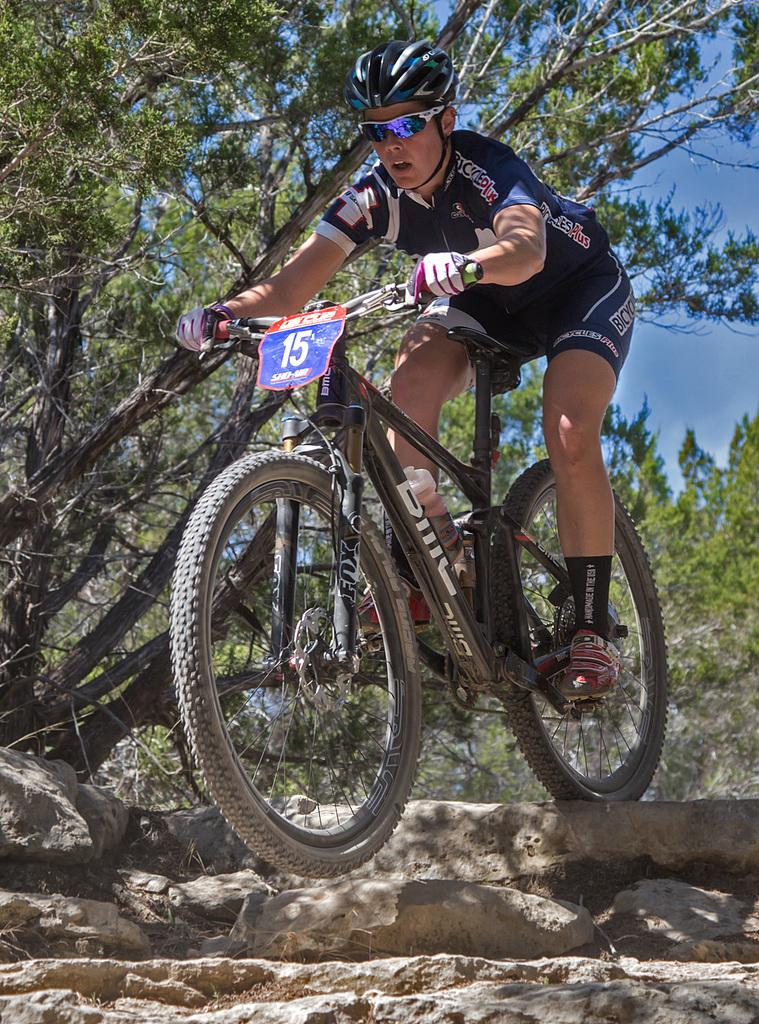What is the main subject of the image? There is a person riding a bicycle in the image. What type of terrain is visible in the image? There are stones visible in the image. What type of vegetation is present in the image? There are trees in the image. What is visible in the background of the image? The sky is visible in the image. What is the name of the cow in the image? There is no cow present in the image. What type of business is being conducted in the image? There is no business activity depicted in the image; it features a person riding a bicycle. 